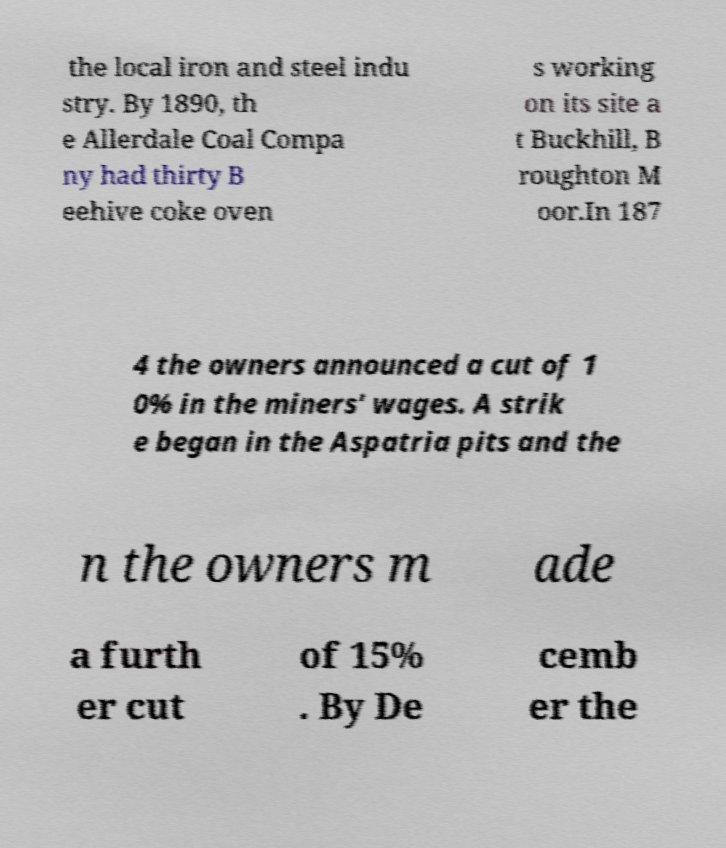Can you read and provide the text displayed in the image?This photo seems to have some interesting text. Can you extract and type it out for me? the local iron and steel indu stry. By 1890, th e Allerdale Coal Compa ny had thirty B eehive coke oven s working on its site a t Buckhill, B roughton M oor.In 187 4 the owners announced a cut of 1 0% in the miners' wages. A strik e began in the Aspatria pits and the n the owners m ade a furth er cut of 15% . By De cemb er the 